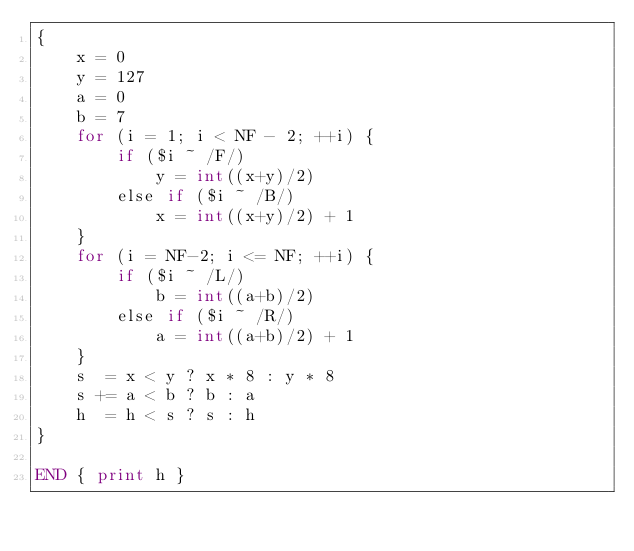Convert code to text. <code><loc_0><loc_0><loc_500><loc_500><_Awk_>{
    x = 0
    y = 127
    a = 0
    b = 7
    for (i = 1; i < NF - 2; ++i) {
        if ($i ~ /F/)
            y = int((x+y)/2)
        else if ($i ~ /B/)
            x = int((x+y)/2) + 1
    }
    for (i = NF-2; i <= NF; ++i) {
        if ($i ~ /L/)
            b = int((a+b)/2)
        else if ($i ~ /R/)
            a = int((a+b)/2) + 1
    }
    s  = x < y ? x * 8 : y * 8
    s += a < b ? b : a
    h  = h < s ? s : h
}

END { print h }
</code> 